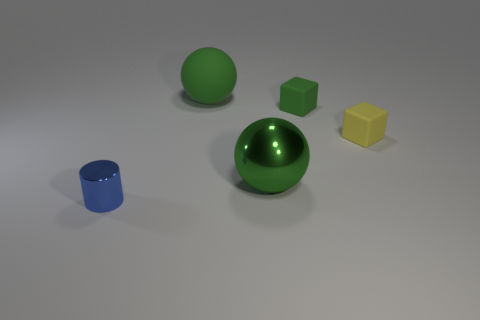What material is the other sphere that is the same color as the metal ball?
Offer a terse response. Rubber. How many big green rubber things are there?
Your answer should be very brief. 1. What number of objects are tiny objects on the right side of the blue thing or big gray cylinders?
Keep it short and to the point. 2. There is a big ball that is right of the large green matte thing; is it the same color as the cylinder?
Ensure brevity in your answer.  No. What number of other things are there of the same color as the shiny ball?
Your answer should be compact. 2. What number of small objects are either rubber blocks or purple cylinders?
Offer a terse response. 2. Is the number of small yellow rubber objects greater than the number of tiny green cylinders?
Offer a very short reply. Yes. Is the tiny green block made of the same material as the blue cylinder?
Give a very brief answer. No. Is the number of metallic cylinders to the right of the large matte sphere greater than the number of green matte things?
Your response must be concise. No. Does the big matte sphere have the same color as the metallic sphere?
Your answer should be very brief. Yes. 